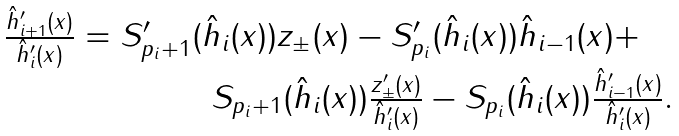Convert formula to latex. <formula><loc_0><loc_0><loc_500><loc_500>\begin{array} { r } \frac { \hat { h } ^ { \prime } _ { i + 1 } ( x ) } { \hat { h } ^ { \prime } _ { i } ( x ) } = S ^ { \prime } _ { p _ { i } + 1 } ( \hat { h } _ { i } ( x ) ) z _ { \pm } ( x ) - S ^ { \prime } _ { p _ { i } } ( \hat { h } _ { i } ( x ) ) \hat { h } _ { i - 1 } ( x ) + \quad \\ S _ { p _ { i } + 1 } ( \hat { h } _ { i } ( x ) ) \frac { z ^ { \prime } _ { \pm } ( x ) } { \hat { h } ^ { \prime } _ { i } ( x ) } - S _ { p _ { i } } ( \hat { h } _ { i } ( x ) ) \frac { \hat { h } ^ { \prime } _ { i - 1 } ( x ) } { \hat { h } ^ { \prime } _ { i } ( x ) } . \end{array}</formula> 